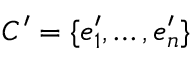Convert formula to latex. <formula><loc_0><loc_0><loc_500><loc_500>C ^ { \prime } = \{ e _ { 1 } ^ { \prime } , \dots , e _ { n } ^ { \prime } \}</formula> 